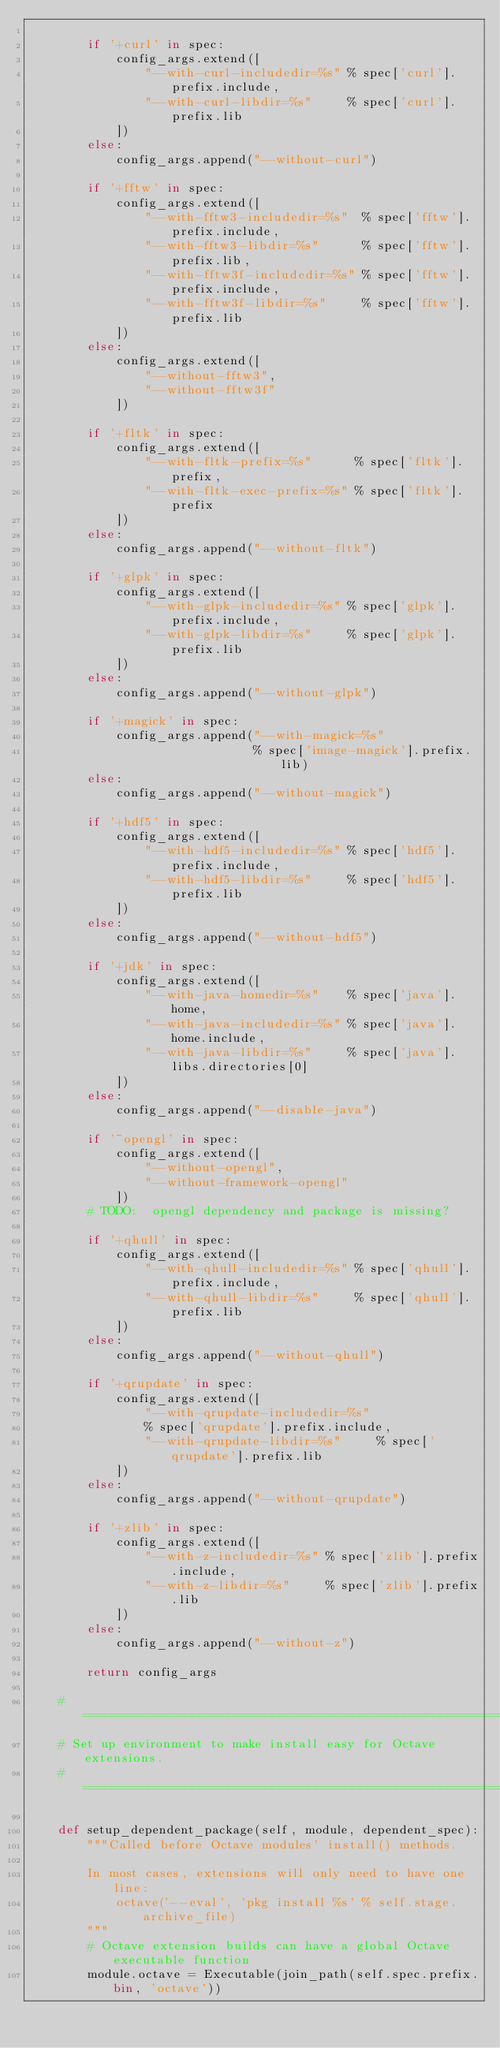<code> <loc_0><loc_0><loc_500><loc_500><_Python_>
        if '+curl' in spec:
            config_args.extend([
                "--with-curl-includedir=%s" % spec['curl'].prefix.include,
                "--with-curl-libdir=%s"     % spec['curl'].prefix.lib
            ])
        else:
            config_args.append("--without-curl")

        if '+fftw' in spec:
            config_args.extend([
                "--with-fftw3-includedir=%s"  % spec['fftw'].prefix.include,
                "--with-fftw3-libdir=%s"      % spec['fftw'].prefix.lib,
                "--with-fftw3f-includedir=%s" % spec['fftw'].prefix.include,
                "--with-fftw3f-libdir=%s"     % spec['fftw'].prefix.lib
            ])
        else:
            config_args.extend([
                "--without-fftw3",
                "--without-fftw3f"
            ])

        if '+fltk' in spec:
            config_args.extend([
                "--with-fltk-prefix=%s"      % spec['fltk'].prefix,
                "--with-fltk-exec-prefix=%s" % spec['fltk'].prefix
            ])
        else:
            config_args.append("--without-fltk")

        if '+glpk' in spec:
            config_args.extend([
                "--with-glpk-includedir=%s" % spec['glpk'].prefix.include,
                "--with-glpk-libdir=%s"     % spec['glpk'].prefix.lib
            ])
        else:
            config_args.append("--without-glpk")

        if '+magick' in spec:
            config_args.append("--with-magick=%s"
                               % spec['image-magick'].prefix.lib)
        else:
            config_args.append("--without-magick")

        if '+hdf5' in spec:
            config_args.extend([
                "--with-hdf5-includedir=%s" % spec['hdf5'].prefix.include,
                "--with-hdf5-libdir=%s"     % spec['hdf5'].prefix.lib
            ])
        else:
            config_args.append("--without-hdf5")

        if '+jdk' in spec:
            config_args.extend([
                "--with-java-homedir=%s"    % spec['java'].home,
                "--with-java-includedir=%s" % spec['java'].home.include,
                "--with-java-libdir=%s"     % spec['java'].libs.directories[0]
            ])
        else:
            config_args.append("--disable-java")

        if '~opengl' in spec:
            config_args.extend([
                "--without-opengl",
                "--without-framework-opengl"
            ])
        # TODO:  opengl dependency and package is missing?

        if '+qhull' in spec:
            config_args.extend([
                "--with-qhull-includedir=%s" % spec['qhull'].prefix.include,
                "--with-qhull-libdir=%s"     % spec['qhull'].prefix.lib
            ])
        else:
            config_args.append("--without-qhull")

        if '+qrupdate' in spec:
            config_args.extend([
                "--with-qrupdate-includedir=%s"
                % spec['qrupdate'].prefix.include,
                "--with-qrupdate-libdir=%s"     % spec['qrupdate'].prefix.lib
            ])
        else:
            config_args.append("--without-qrupdate")

        if '+zlib' in spec:
            config_args.extend([
                "--with-z-includedir=%s" % spec['zlib'].prefix.include,
                "--with-z-libdir=%s"     % spec['zlib'].prefix.lib
            ])
        else:
            config_args.append("--without-z")

        return config_args

    # ========================================================================
    # Set up environment to make install easy for Octave extensions.
    # ========================================================================

    def setup_dependent_package(self, module, dependent_spec):
        """Called before Octave modules' install() methods.

        In most cases, extensions will only need to have one line:
            octave('--eval', 'pkg install %s' % self.stage.archive_file)
        """
        # Octave extension builds can have a global Octave executable function
        module.octave = Executable(join_path(self.spec.prefix.bin, 'octave'))
</code> 